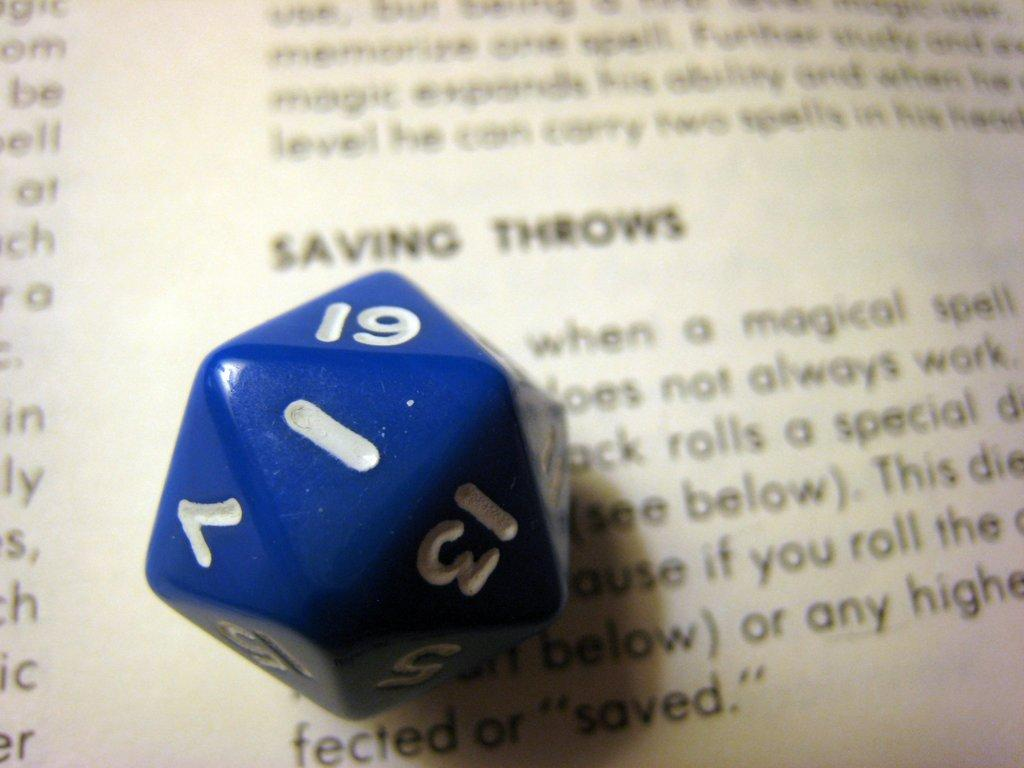What object can be seen in the image? There is a dice in the image. What else is visible in the background of the image? There is a paper in the background of the image. Can you describe the paper in the image? The paper has text on it. How many ants are crawling on the dice in the image? There are no ants present in the image. What type of sorting method is being used on the dice in the image? The image does not depict any sorting method being applied to the dice. 